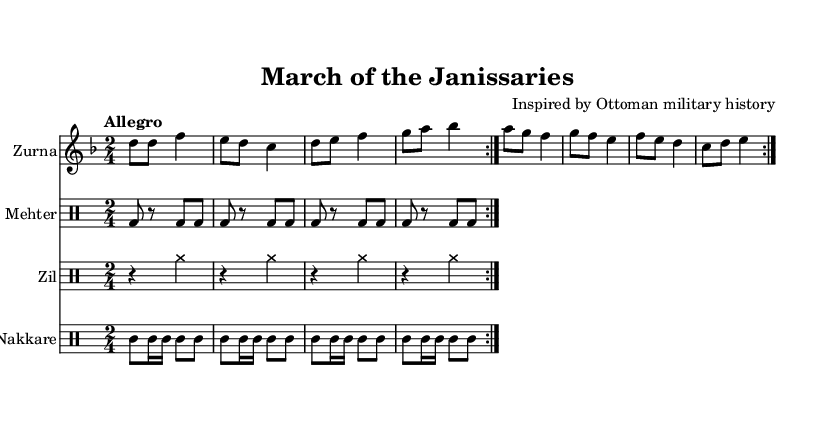What is the key signature of this music? The key signature indicated at the beginning of the staff is one flat, meaning it is in D minor, which consists of D, E, F, G, A, B♭, C.
Answer: D minor What is the time signature of this music? The time signature shown at the beginning of the score is 2/4, which means there are two beats in each measure and the quarter note gets one beat.
Answer: 2/4 What is the tempo marking for this piece? The tempo marking at the beginning is "Allegro," which indicates a fast, lively tempo typically between 120 and 168 beats per minute.
Answer: Allegro How many times is the zurna part repeated? The instruction "repeat volta 2" indicates that the zurna section is played two times in total.
Answer: 2 What instruments are part of the ensemble in this score? Four distinct instrumental parts are indicated: Zurna, Mehter, Zil, and Nakkare, showcasing a blend of melody and percussion typical in traditional Ottoman music.
Answer: Zurna, Mehter, Zil, Nakkare What type of musical form is reflected in the zurna section? The notation includes repeated sections with the volta markings, which suggest a simple ternary or binary form often used in marches.
Answer: Repeat form How does the mehter rhythm contribute to the overall feel of the piece? The rhythmic patterns in the mehter part are characterized by a consistent backbeat, maintaining a martial and energetic feel that supports the march's atmosphere.
Answer: Martial feel 